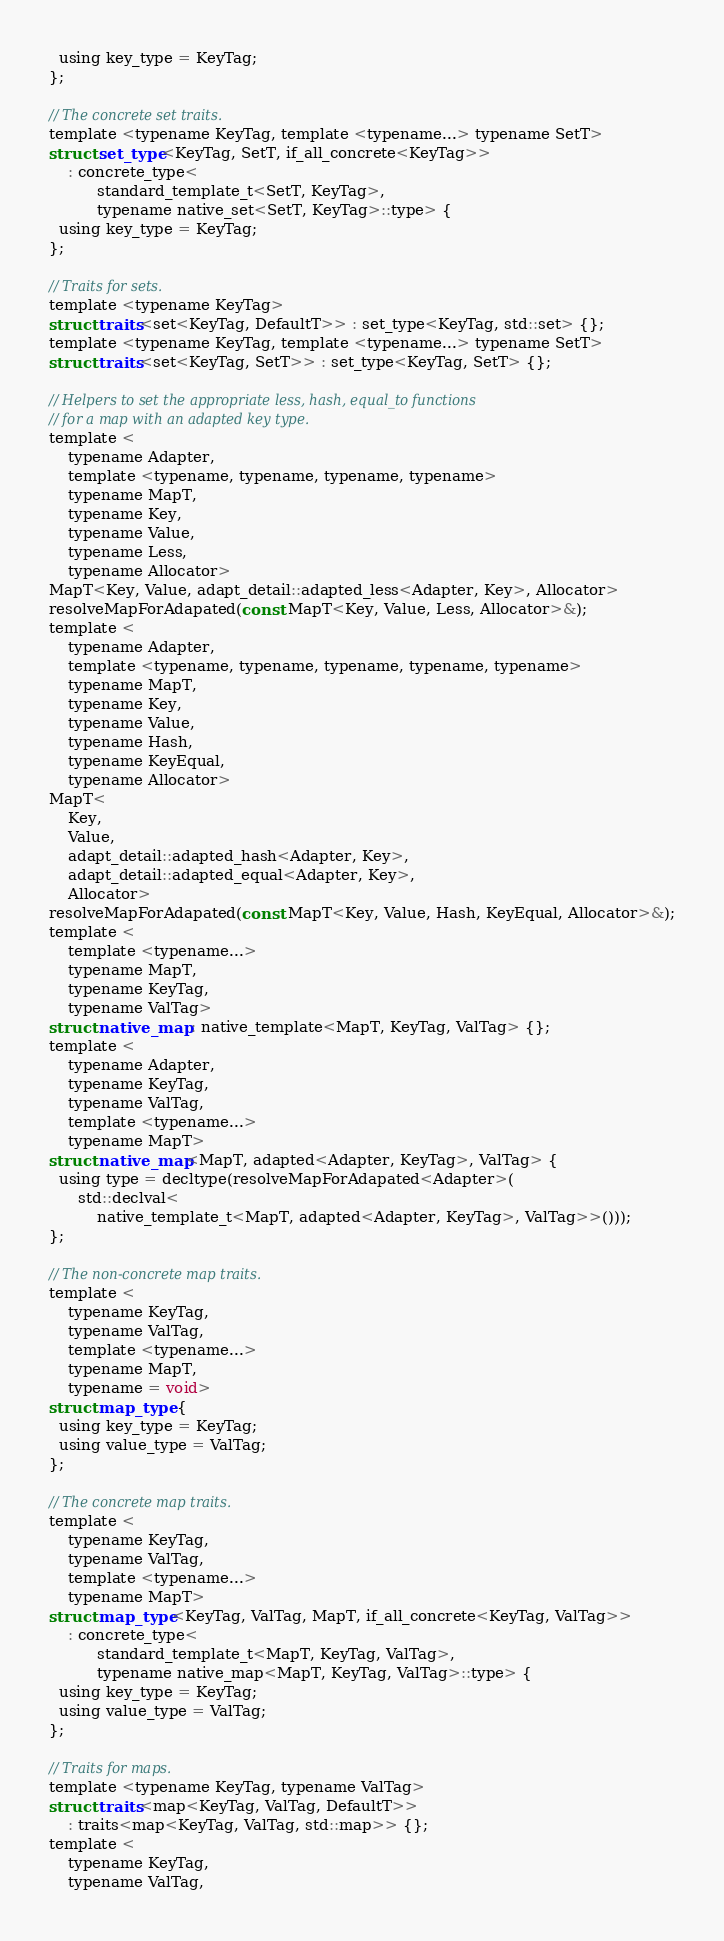<code> <loc_0><loc_0><loc_500><loc_500><_C_>  using key_type = KeyTag;
};

// The concrete set traits.
template <typename KeyTag, template <typename...> typename SetT>
struct set_type<KeyTag, SetT, if_all_concrete<KeyTag>>
    : concrete_type<
          standard_template_t<SetT, KeyTag>,
          typename native_set<SetT, KeyTag>::type> {
  using key_type = KeyTag;
};

// Traits for sets.
template <typename KeyTag>
struct traits<set<KeyTag, DefaultT>> : set_type<KeyTag, std::set> {};
template <typename KeyTag, template <typename...> typename SetT>
struct traits<set<KeyTag, SetT>> : set_type<KeyTag, SetT> {};

// Helpers to set the appropriate less, hash, equal_to functions
// for a map with an adapted key type.
template <
    typename Adapter,
    template <typename, typename, typename, typename>
    typename MapT,
    typename Key,
    typename Value,
    typename Less,
    typename Allocator>
MapT<Key, Value, adapt_detail::adapted_less<Adapter, Key>, Allocator>
resolveMapForAdapated(const MapT<Key, Value, Less, Allocator>&);
template <
    typename Adapter,
    template <typename, typename, typename, typename, typename>
    typename MapT,
    typename Key,
    typename Value,
    typename Hash,
    typename KeyEqual,
    typename Allocator>
MapT<
    Key,
    Value,
    adapt_detail::adapted_hash<Adapter, Key>,
    adapt_detail::adapted_equal<Adapter, Key>,
    Allocator>
resolveMapForAdapated(const MapT<Key, Value, Hash, KeyEqual, Allocator>&);
template <
    template <typename...>
    typename MapT,
    typename KeyTag,
    typename ValTag>
struct native_map : native_template<MapT, KeyTag, ValTag> {};
template <
    typename Adapter,
    typename KeyTag,
    typename ValTag,
    template <typename...>
    typename MapT>
struct native_map<MapT, adapted<Adapter, KeyTag>, ValTag> {
  using type = decltype(resolveMapForAdapated<Adapter>(
      std::declval<
          native_template_t<MapT, adapted<Adapter, KeyTag>, ValTag>>()));
};

// The non-concrete map traits.
template <
    typename KeyTag,
    typename ValTag,
    template <typename...>
    typename MapT,
    typename = void>
struct map_type {
  using key_type = KeyTag;
  using value_type = ValTag;
};

// The concrete map traits.
template <
    typename KeyTag,
    typename ValTag,
    template <typename...>
    typename MapT>
struct map_type<KeyTag, ValTag, MapT, if_all_concrete<KeyTag, ValTag>>
    : concrete_type<
          standard_template_t<MapT, KeyTag, ValTag>,
          typename native_map<MapT, KeyTag, ValTag>::type> {
  using key_type = KeyTag;
  using value_type = ValTag;
};

// Traits for maps.
template <typename KeyTag, typename ValTag>
struct traits<map<KeyTag, ValTag, DefaultT>>
    : traits<map<KeyTag, ValTag, std::map>> {};
template <
    typename KeyTag,
    typename ValTag,</code> 